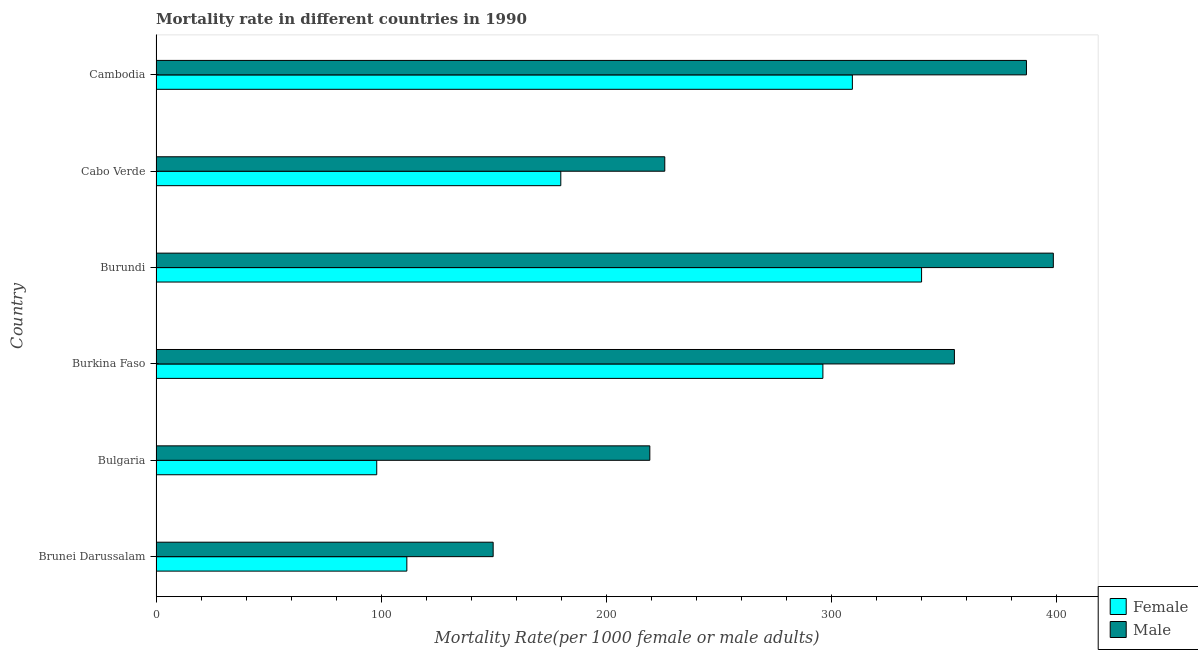Are the number of bars per tick equal to the number of legend labels?
Offer a very short reply. Yes. How many bars are there on the 5th tick from the top?
Offer a terse response. 2. How many bars are there on the 6th tick from the bottom?
Your response must be concise. 2. What is the label of the 2nd group of bars from the top?
Offer a terse response. Cabo Verde. What is the female mortality rate in Bulgaria?
Provide a short and direct response. 98.03. Across all countries, what is the maximum male mortality rate?
Offer a very short reply. 398.54. Across all countries, what is the minimum male mortality rate?
Make the answer very short. 149.74. In which country was the female mortality rate maximum?
Provide a short and direct response. Burundi. In which country was the male mortality rate minimum?
Your answer should be very brief. Brunei Darussalam. What is the total male mortality rate in the graph?
Your answer should be compact. 1734.77. What is the difference between the female mortality rate in Brunei Darussalam and that in Burkina Faso?
Keep it short and to the point. -184.79. What is the difference between the male mortality rate in Burundi and the female mortality rate in Burkina Faso?
Offer a terse response. 102.35. What is the average male mortality rate per country?
Your answer should be very brief. 289.13. What is the difference between the male mortality rate and female mortality rate in Bulgaria?
Your answer should be compact. 121.3. In how many countries, is the male mortality rate greater than 100 ?
Ensure brevity in your answer.  6. What is the ratio of the male mortality rate in Brunei Darussalam to that in Burkina Faso?
Your answer should be compact. 0.42. Is the female mortality rate in Bulgaria less than that in Burkina Faso?
Offer a very short reply. Yes. What is the difference between the highest and the second highest male mortality rate?
Keep it short and to the point. 11.94. What is the difference between the highest and the lowest male mortality rate?
Provide a short and direct response. 248.8. In how many countries, is the female mortality rate greater than the average female mortality rate taken over all countries?
Give a very brief answer. 3. Is the sum of the male mortality rate in Burkina Faso and Cabo Verde greater than the maximum female mortality rate across all countries?
Offer a terse response. Yes. What does the 1st bar from the top in Burkina Faso represents?
Your answer should be compact. Male. Are all the bars in the graph horizontal?
Make the answer very short. Yes. Does the graph contain grids?
Your answer should be very brief. No. How many legend labels are there?
Ensure brevity in your answer.  2. How are the legend labels stacked?
Your answer should be compact. Vertical. What is the title of the graph?
Ensure brevity in your answer.  Mortality rate in different countries in 1990. Does "Study and work" appear as one of the legend labels in the graph?
Your answer should be very brief. No. What is the label or title of the X-axis?
Provide a succinct answer. Mortality Rate(per 1000 female or male adults). What is the Mortality Rate(per 1000 female or male adults) in Female in Brunei Darussalam?
Your answer should be very brief. 111.4. What is the Mortality Rate(per 1000 female or male adults) in Male in Brunei Darussalam?
Your answer should be compact. 149.74. What is the Mortality Rate(per 1000 female or male adults) in Female in Bulgaria?
Keep it short and to the point. 98.03. What is the Mortality Rate(per 1000 female or male adults) in Male in Bulgaria?
Your response must be concise. 219.33. What is the Mortality Rate(per 1000 female or male adults) in Female in Burkina Faso?
Offer a very short reply. 296.19. What is the Mortality Rate(per 1000 female or male adults) in Male in Burkina Faso?
Give a very brief answer. 354.6. What is the Mortality Rate(per 1000 female or male adults) in Female in Burundi?
Keep it short and to the point. 340.03. What is the Mortality Rate(per 1000 female or male adults) of Male in Burundi?
Offer a terse response. 398.54. What is the Mortality Rate(per 1000 female or male adults) in Female in Cabo Verde?
Offer a very short reply. 179.78. What is the Mortality Rate(per 1000 female or male adults) of Male in Cabo Verde?
Your answer should be compact. 225.97. What is the Mortality Rate(per 1000 female or male adults) of Female in Cambodia?
Ensure brevity in your answer.  309.29. What is the Mortality Rate(per 1000 female or male adults) in Male in Cambodia?
Your response must be concise. 386.6. Across all countries, what is the maximum Mortality Rate(per 1000 female or male adults) in Female?
Provide a short and direct response. 340.03. Across all countries, what is the maximum Mortality Rate(per 1000 female or male adults) in Male?
Offer a very short reply. 398.54. Across all countries, what is the minimum Mortality Rate(per 1000 female or male adults) in Female?
Provide a short and direct response. 98.03. Across all countries, what is the minimum Mortality Rate(per 1000 female or male adults) of Male?
Provide a succinct answer. 149.74. What is the total Mortality Rate(per 1000 female or male adults) of Female in the graph?
Ensure brevity in your answer.  1334.72. What is the total Mortality Rate(per 1000 female or male adults) in Male in the graph?
Offer a terse response. 1734.77. What is the difference between the Mortality Rate(per 1000 female or male adults) of Female in Brunei Darussalam and that in Bulgaria?
Your answer should be very brief. 13.37. What is the difference between the Mortality Rate(per 1000 female or male adults) in Male in Brunei Darussalam and that in Bulgaria?
Provide a succinct answer. -69.59. What is the difference between the Mortality Rate(per 1000 female or male adults) in Female in Brunei Darussalam and that in Burkina Faso?
Provide a succinct answer. -184.79. What is the difference between the Mortality Rate(per 1000 female or male adults) of Male in Brunei Darussalam and that in Burkina Faso?
Offer a terse response. -204.87. What is the difference between the Mortality Rate(per 1000 female or male adults) in Female in Brunei Darussalam and that in Burundi?
Make the answer very short. -228.62. What is the difference between the Mortality Rate(per 1000 female or male adults) in Male in Brunei Darussalam and that in Burundi?
Provide a succinct answer. -248.81. What is the difference between the Mortality Rate(per 1000 female or male adults) of Female in Brunei Darussalam and that in Cabo Verde?
Provide a succinct answer. -68.38. What is the difference between the Mortality Rate(per 1000 female or male adults) in Male in Brunei Darussalam and that in Cabo Verde?
Offer a very short reply. -76.23. What is the difference between the Mortality Rate(per 1000 female or male adults) in Female in Brunei Darussalam and that in Cambodia?
Provide a succinct answer. -197.89. What is the difference between the Mortality Rate(per 1000 female or male adults) of Male in Brunei Darussalam and that in Cambodia?
Your response must be concise. -236.87. What is the difference between the Mortality Rate(per 1000 female or male adults) in Female in Bulgaria and that in Burkina Faso?
Your answer should be compact. -198.16. What is the difference between the Mortality Rate(per 1000 female or male adults) of Male in Bulgaria and that in Burkina Faso?
Ensure brevity in your answer.  -135.28. What is the difference between the Mortality Rate(per 1000 female or male adults) in Female in Bulgaria and that in Burundi?
Your answer should be compact. -242. What is the difference between the Mortality Rate(per 1000 female or male adults) of Male in Bulgaria and that in Burundi?
Your response must be concise. -179.22. What is the difference between the Mortality Rate(per 1000 female or male adults) of Female in Bulgaria and that in Cabo Verde?
Ensure brevity in your answer.  -81.75. What is the difference between the Mortality Rate(per 1000 female or male adults) in Male in Bulgaria and that in Cabo Verde?
Keep it short and to the point. -6.64. What is the difference between the Mortality Rate(per 1000 female or male adults) in Female in Bulgaria and that in Cambodia?
Give a very brief answer. -211.26. What is the difference between the Mortality Rate(per 1000 female or male adults) in Male in Bulgaria and that in Cambodia?
Your answer should be very brief. -167.28. What is the difference between the Mortality Rate(per 1000 female or male adults) of Female in Burkina Faso and that in Burundi?
Ensure brevity in your answer.  -43.84. What is the difference between the Mortality Rate(per 1000 female or male adults) of Male in Burkina Faso and that in Burundi?
Your answer should be compact. -43.94. What is the difference between the Mortality Rate(per 1000 female or male adults) of Female in Burkina Faso and that in Cabo Verde?
Offer a very short reply. 116.41. What is the difference between the Mortality Rate(per 1000 female or male adults) in Male in Burkina Faso and that in Cabo Verde?
Keep it short and to the point. 128.64. What is the difference between the Mortality Rate(per 1000 female or male adults) of Female in Burkina Faso and that in Cambodia?
Make the answer very short. -13.1. What is the difference between the Mortality Rate(per 1000 female or male adults) in Male in Burkina Faso and that in Cambodia?
Offer a very short reply. -32. What is the difference between the Mortality Rate(per 1000 female or male adults) of Female in Burundi and that in Cabo Verde?
Your answer should be very brief. 160.24. What is the difference between the Mortality Rate(per 1000 female or male adults) of Male in Burundi and that in Cabo Verde?
Provide a succinct answer. 172.57. What is the difference between the Mortality Rate(per 1000 female or male adults) of Female in Burundi and that in Cambodia?
Your answer should be compact. 30.74. What is the difference between the Mortality Rate(per 1000 female or male adults) of Male in Burundi and that in Cambodia?
Provide a succinct answer. 11.94. What is the difference between the Mortality Rate(per 1000 female or male adults) of Female in Cabo Verde and that in Cambodia?
Keep it short and to the point. -129.51. What is the difference between the Mortality Rate(per 1000 female or male adults) of Male in Cabo Verde and that in Cambodia?
Provide a succinct answer. -160.64. What is the difference between the Mortality Rate(per 1000 female or male adults) in Female in Brunei Darussalam and the Mortality Rate(per 1000 female or male adults) in Male in Bulgaria?
Offer a terse response. -107.92. What is the difference between the Mortality Rate(per 1000 female or male adults) in Female in Brunei Darussalam and the Mortality Rate(per 1000 female or male adults) in Male in Burkina Faso?
Provide a succinct answer. -243.2. What is the difference between the Mortality Rate(per 1000 female or male adults) in Female in Brunei Darussalam and the Mortality Rate(per 1000 female or male adults) in Male in Burundi?
Keep it short and to the point. -287.14. What is the difference between the Mortality Rate(per 1000 female or male adults) of Female in Brunei Darussalam and the Mortality Rate(per 1000 female or male adults) of Male in Cabo Verde?
Keep it short and to the point. -114.56. What is the difference between the Mortality Rate(per 1000 female or male adults) in Female in Brunei Darussalam and the Mortality Rate(per 1000 female or male adults) in Male in Cambodia?
Provide a succinct answer. -275.2. What is the difference between the Mortality Rate(per 1000 female or male adults) in Female in Bulgaria and the Mortality Rate(per 1000 female or male adults) in Male in Burkina Faso?
Ensure brevity in your answer.  -256.57. What is the difference between the Mortality Rate(per 1000 female or male adults) of Female in Bulgaria and the Mortality Rate(per 1000 female or male adults) of Male in Burundi?
Your answer should be very brief. -300.51. What is the difference between the Mortality Rate(per 1000 female or male adults) of Female in Bulgaria and the Mortality Rate(per 1000 female or male adults) of Male in Cabo Verde?
Ensure brevity in your answer.  -127.94. What is the difference between the Mortality Rate(per 1000 female or male adults) of Female in Bulgaria and the Mortality Rate(per 1000 female or male adults) of Male in Cambodia?
Your answer should be compact. -288.57. What is the difference between the Mortality Rate(per 1000 female or male adults) in Female in Burkina Faso and the Mortality Rate(per 1000 female or male adults) in Male in Burundi?
Your answer should be compact. -102.35. What is the difference between the Mortality Rate(per 1000 female or male adults) in Female in Burkina Faso and the Mortality Rate(per 1000 female or male adults) in Male in Cabo Verde?
Ensure brevity in your answer.  70.22. What is the difference between the Mortality Rate(per 1000 female or male adults) in Female in Burkina Faso and the Mortality Rate(per 1000 female or male adults) in Male in Cambodia?
Ensure brevity in your answer.  -90.41. What is the difference between the Mortality Rate(per 1000 female or male adults) in Female in Burundi and the Mortality Rate(per 1000 female or male adults) in Male in Cabo Verde?
Give a very brief answer. 114.06. What is the difference between the Mortality Rate(per 1000 female or male adults) of Female in Burundi and the Mortality Rate(per 1000 female or male adults) of Male in Cambodia?
Your answer should be compact. -46.58. What is the difference between the Mortality Rate(per 1000 female or male adults) of Female in Cabo Verde and the Mortality Rate(per 1000 female or male adults) of Male in Cambodia?
Offer a terse response. -206.82. What is the average Mortality Rate(per 1000 female or male adults) in Female per country?
Make the answer very short. 222.45. What is the average Mortality Rate(per 1000 female or male adults) in Male per country?
Ensure brevity in your answer.  289.13. What is the difference between the Mortality Rate(per 1000 female or male adults) of Female and Mortality Rate(per 1000 female or male adults) of Male in Brunei Darussalam?
Your response must be concise. -38.34. What is the difference between the Mortality Rate(per 1000 female or male adults) in Female and Mortality Rate(per 1000 female or male adults) in Male in Bulgaria?
Your answer should be very brief. -121.3. What is the difference between the Mortality Rate(per 1000 female or male adults) in Female and Mortality Rate(per 1000 female or male adults) in Male in Burkina Faso?
Your answer should be compact. -58.41. What is the difference between the Mortality Rate(per 1000 female or male adults) of Female and Mortality Rate(per 1000 female or male adults) of Male in Burundi?
Keep it short and to the point. -58.52. What is the difference between the Mortality Rate(per 1000 female or male adults) of Female and Mortality Rate(per 1000 female or male adults) of Male in Cabo Verde?
Offer a terse response. -46.18. What is the difference between the Mortality Rate(per 1000 female or male adults) in Female and Mortality Rate(per 1000 female or male adults) in Male in Cambodia?
Ensure brevity in your answer.  -77.31. What is the ratio of the Mortality Rate(per 1000 female or male adults) of Female in Brunei Darussalam to that in Bulgaria?
Provide a succinct answer. 1.14. What is the ratio of the Mortality Rate(per 1000 female or male adults) in Male in Brunei Darussalam to that in Bulgaria?
Provide a succinct answer. 0.68. What is the ratio of the Mortality Rate(per 1000 female or male adults) of Female in Brunei Darussalam to that in Burkina Faso?
Your answer should be very brief. 0.38. What is the ratio of the Mortality Rate(per 1000 female or male adults) in Male in Brunei Darussalam to that in Burkina Faso?
Provide a short and direct response. 0.42. What is the ratio of the Mortality Rate(per 1000 female or male adults) of Female in Brunei Darussalam to that in Burundi?
Give a very brief answer. 0.33. What is the ratio of the Mortality Rate(per 1000 female or male adults) of Male in Brunei Darussalam to that in Burundi?
Your answer should be compact. 0.38. What is the ratio of the Mortality Rate(per 1000 female or male adults) of Female in Brunei Darussalam to that in Cabo Verde?
Keep it short and to the point. 0.62. What is the ratio of the Mortality Rate(per 1000 female or male adults) in Male in Brunei Darussalam to that in Cabo Verde?
Keep it short and to the point. 0.66. What is the ratio of the Mortality Rate(per 1000 female or male adults) in Female in Brunei Darussalam to that in Cambodia?
Offer a terse response. 0.36. What is the ratio of the Mortality Rate(per 1000 female or male adults) of Male in Brunei Darussalam to that in Cambodia?
Offer a terse response. 0.39. What is the ratio of the Mortality Rate(per 1000 female or male adults) of Female in Bulgaria to that in Burkina Faso?
Keep it short and to the point. 0.33. What is the ratio of the Mortality Rate(per 1000 female or male adults) of Male in Bulgaria to that in Burkina Faso?
Keep it short and to the point. 0.62. What is the ratio of the Mortality Rate(per 1000 female or male adults) in Female in Bulgaria to that in Burundi?
Make the answer very short. 0.29. What is the ratio of the Mortality Rate(per 1000 female or male adults) in Male in Bulgaria to that in Burundi?
Offer a very short reply. 0.55. What is the ratio of the Mortality Rate(per 1000 female or male adults) in Female in Bulgaria to that in Cabo Verde?
Your answer should be very brief. 0.55. What is the ratio of the Mortality Rate(per 1000 female or male adults) of Male in Bulgaria to that in Cabo Verde?
Your response must be concise. 0.97. What is the ratio of the Mortality Rate(per 1000 female or male adults) of Female in Bulgaria to that in Cambodia?
Provide a short and direct response. 0.32. What is the ratio of the Mortality Rate(per 1000 female or male adults) in Male in Bulgaria to that in Cambodia?
Ensure brevity in your answer.  0.57. What is the ratio of the Mortality Rate(per 1000 female or male adults) in Female in Burkina Faso to that in Burundi?
Ensure brevity in your answer.  0.87. What is the ratio of the Mortality Rate(per 1000 female or male adults) of Male in Burkina Faso to that in Burundi?
Your answer should be very brief. 0.89. What is the ratio of the Mortality Rate(per 1000 female or male adults) in Female in Burkina Faso to that in Cabo Verde?
Your answer should be very brief. 1.65. What is the ratio of the Mortality Rate(per 1000 female or male adults) in Male in Burkina Faso to that in Cabo Verde?
Keep it short and to the point. 1.57. What is the ratio of the Mortality Rate(per 1000 female or male adults) in Female in Burkina Faso to that in Cambodia?
Your response must be concise. 0.96. What is the ratio of the Mortality Rate(per 1000 female or male adults) in Male in Burkina Faso to that in Cambodia?
Your response must be concise. 0.92. What is the ratio of the Mortality Rate(per 1000 female or male adults) of Female in Burundi to that in Cabo Verde?
Offer a very short reply. 1.89. What is the ratio of the Mortality Rate(per 1000 female or male adults) of Male in Burundi to that in Cabo Verde?
Offer a terse response. 1.76. What is the ratio of the Mortality Rate(per 1000 female or male adults) of Female in Burundi to that in Cambodia?
Your answer should be compact. 1.1. What is the ratio of the Mortality Rate(per 1000 female or male adults) in Male in Burundi to that in Cambodia?
Offer a terse response. 1.03. What is the ratio of the Mortality Rate(per 1000 female or male adults) of Female in Cabo Verde to that in Cambodia?
Offer a very short reply. 0.58. What is the ratio of the Mortality Rate(per 1000 female or male adults) in Male in Cabo Verde to that in Cambodia?
Provide a succinct answer. 0.58. What is the difference between the highest and the second highest Mortality Rate(per 1000 female or male adults) of Female?
Your response must be concise. 30.74. What is the difference between the highest and the second highest Mortality Rate(per 1000 female or male adults) of Male?
Offer a terse response. 11.94. What is the difference between the highest and the lowest Mortality Rate(per 1000 female or male adults) in Female?
Your response must be concise. 242. What is the difference between the highest and the lowest Mortality Rate(per 1000 female or male adults) in Male?
Provide a succinct answer. 248.81. 